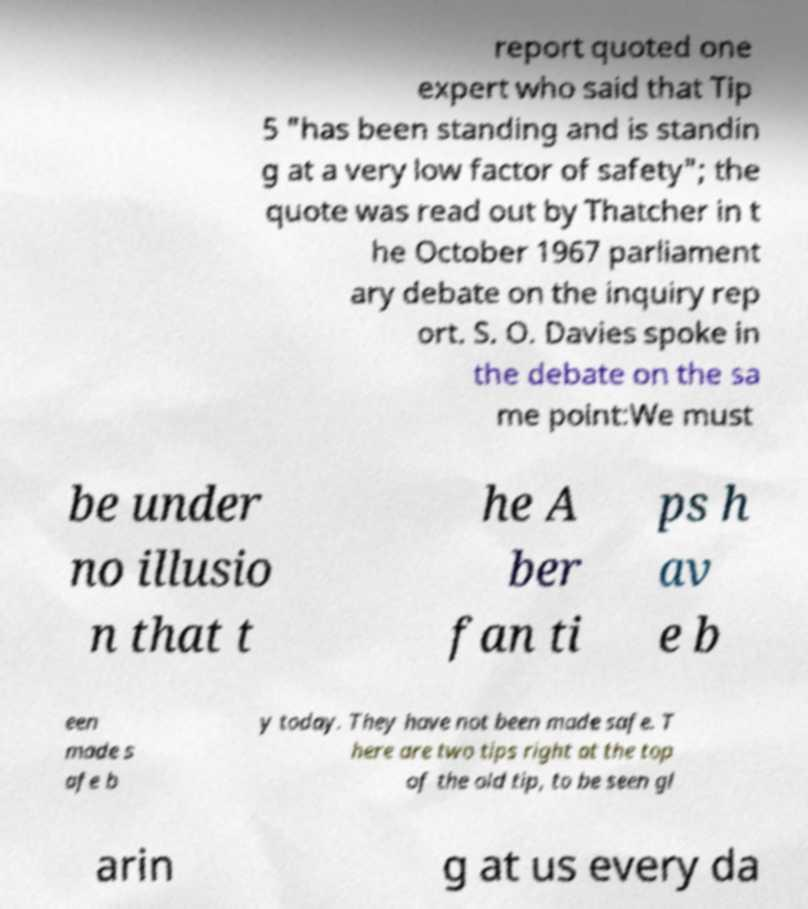Please identify and transcribe the text found in this image. report quoted one expert who said that Tip 5 "has been standing and is standin g at a very low factor of safety"; the quote was read out by Thatcher in t he October 1967 parliament ary debate on the inquiry rep ort. S. O. Davies spoke in the debate on the sa me point:We must be under no illusio n that t he A ber fan ti ps h av e b een made s afe b y today. They have not been made safe. T here are two tips right at the top of the old tip, to be seen gl arin g at us every da 